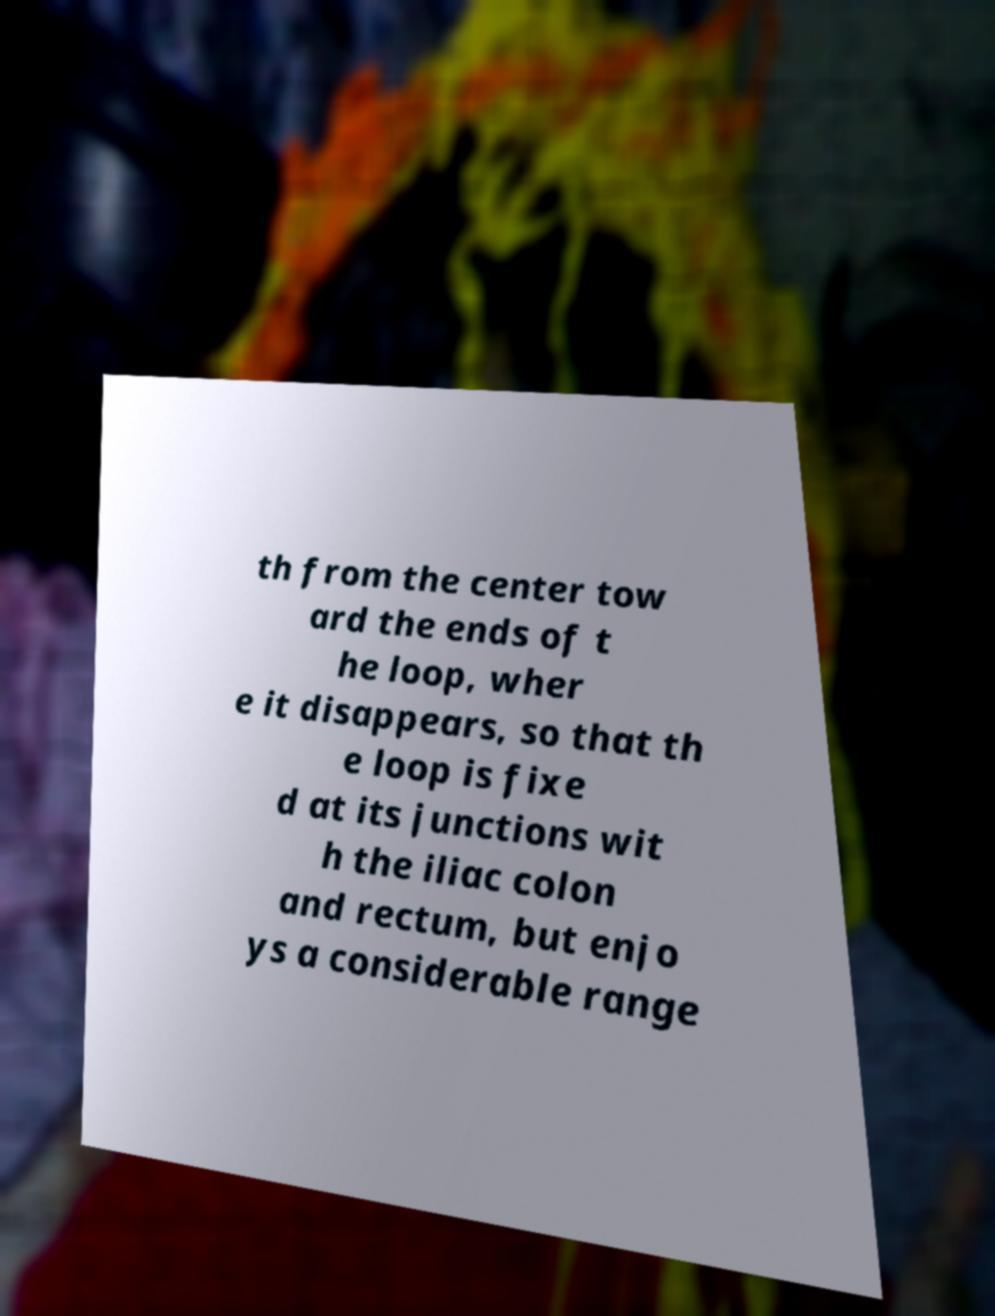Can you read and provide the text displayed in the image?This photo seems to have some interesting text. Can you extract and type it out for me? th from the center tow ard the ends of t he loop, wher e it disappears, so that th e loop is fixe d at its junctions wit h the iliac colon and rectum, but enjo ys a considerable range 